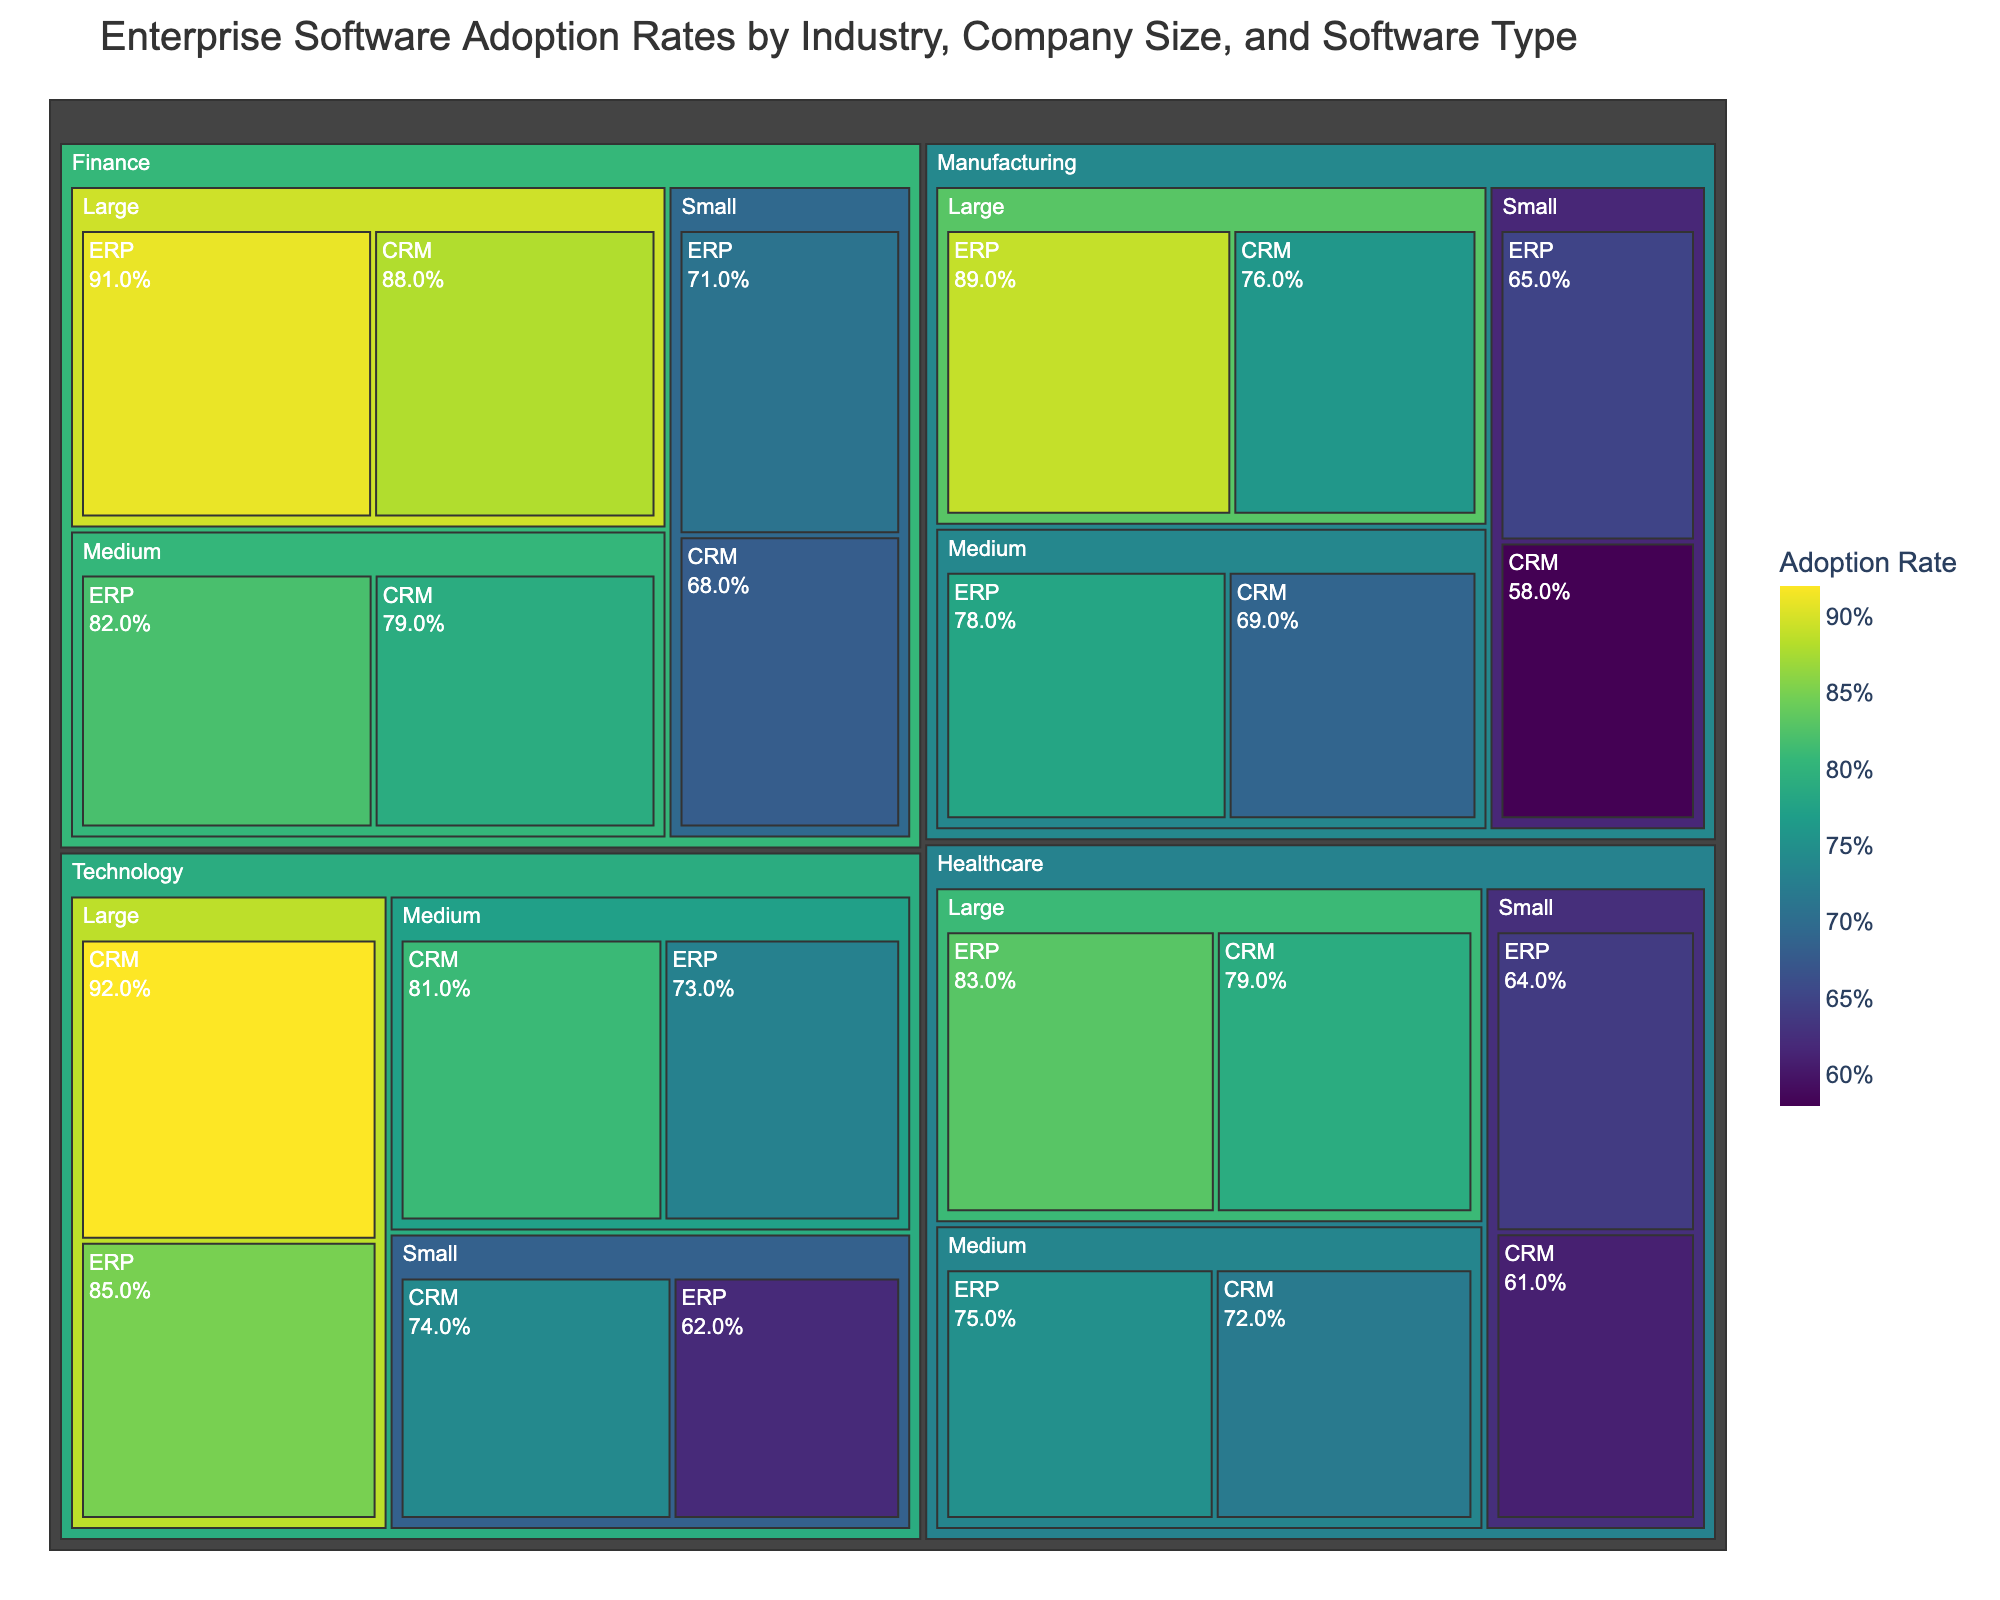Which industry has the highest ERP adoption rate among large companies? To answer this, locate the 'Large' company size within each industry and observe their ERP adoption rates. The industries listed in the data are Technology, Manufacturing, Finance, and Healthcare. Comparing the ERP adoption rates for large companies in these industries, Finance has the highest with 0.91.
Answer: Finance What is the average adoption rate of CRM software across all companies in the Technology industry? First, identify the CRM adoption rates for all companies in the Technology industry: 0.92 (Large), 0.81 (Medium), and 0.74 (Small). Sum these values: 0.92 + 0.81 + 0.74 = 2.47. Divide by the number of observations (3): 2.47 / 3 = 0.8233.
Answer: 0.8233 How does the adoption rate of ERP software for medium-sized companies in the Healthcare industry compare to that of the Manufacturing industry? Locate the ERP adoption rate for medium-sized companies in both Healthcare (0.75) and Manufacturing (0.78) industries. Comparing these, Manufacturing has a higher adoption rate (0.78 > 0.75).
Answer: Manufacturing has a higher rate What's the combined adoption rate of ERP software across all company sizes in the Finance industry? Identify the ERP adoption rates for Finance across all company sizes: Large (0.91), Medium (0.82), and Small (0.71). Sum these values: 0.91 + 0.82 + 0.71 = 2.44.
Answer: 2.44 Which company size in the Manufacturing industry has the lowest CRM adoption rate? Locate the CRM adoption rates for different company sizes in the Manufacturing industry: Large (0.76), Medium (0.69), and Small (0.58). The Small company size has the lowest rate (0.58).
Answer: Small What is the difference between the highest and lowest CRM adoption rates in the Technology industry? Identify the highest and lowest CRM adoption rates in the Technology industry: highest (Large, 0.92) and lowest (Small, 0.74). The difference is 0.92 - 0.74 = 0.18.
Answer: 0.18 Is there any industry where the adoption rates of both ERP and CRM software are higher for large companies than for medium ones? For each industry, compare ERP and CRM adoption rates between large and medium companies. In the Technology, Manufacturing, Finance, and Healthcare industries, all large companies have higher adoption rates for both ERP and CRM compared to medium ones.
Answer: Yes, in all industries Which software type has a more uniform adoption rate across small companies in different industries, ERP or CRM? Compare the ERP and CRM adoption rates for small companies across Technology, Manufacturing, Finance, and Healthcare industries. ERP: 0.62, 0.65, 0.71, 0.64; CRM: 0.74, 0.58, 0.68, 0.61. The variance for ERP rates (0.010) is lower than for CRM rates (0.044), indicating more uniform adoption.
Answer: ERP How does the adoption rate of CRM software for large companies in the Technology industry compare to ERP software for medium companies in the Finance industry? The CRM adoption rate for large companies in Technology is 0.92, while the ERP adoption rate for medium companies in Finance is 0.82. Comparing these values, CRM in Technology is higher (0.92 > 0.82).
Answer: Higher in Technology industry 